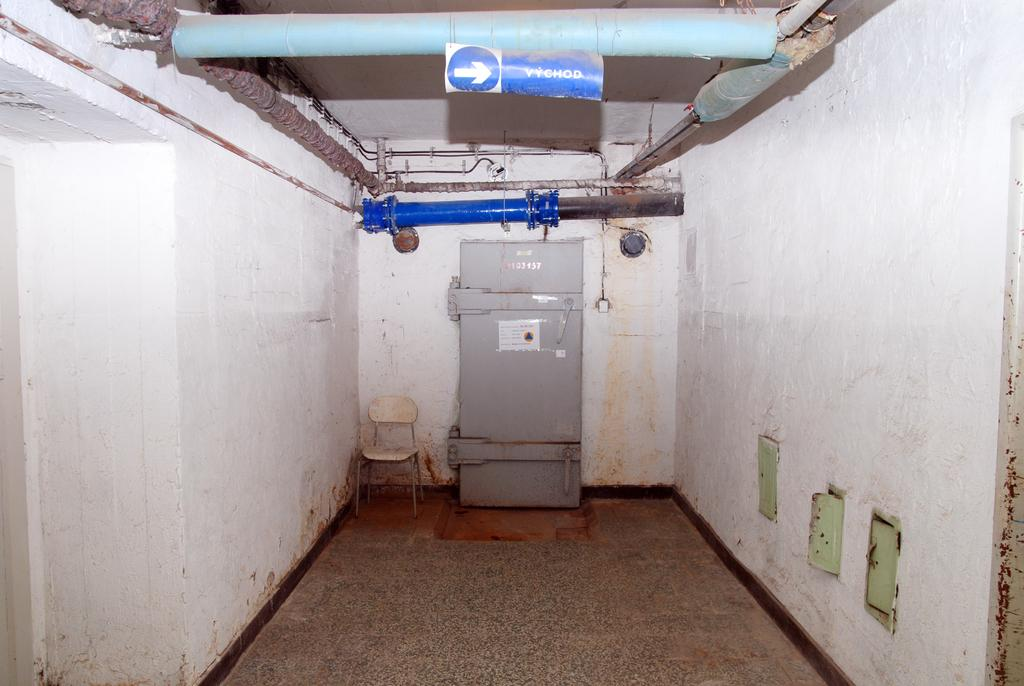<image>
Write a terse but informative summary of the picture. A blue and white arrow sign points the way to VYCHOD. 